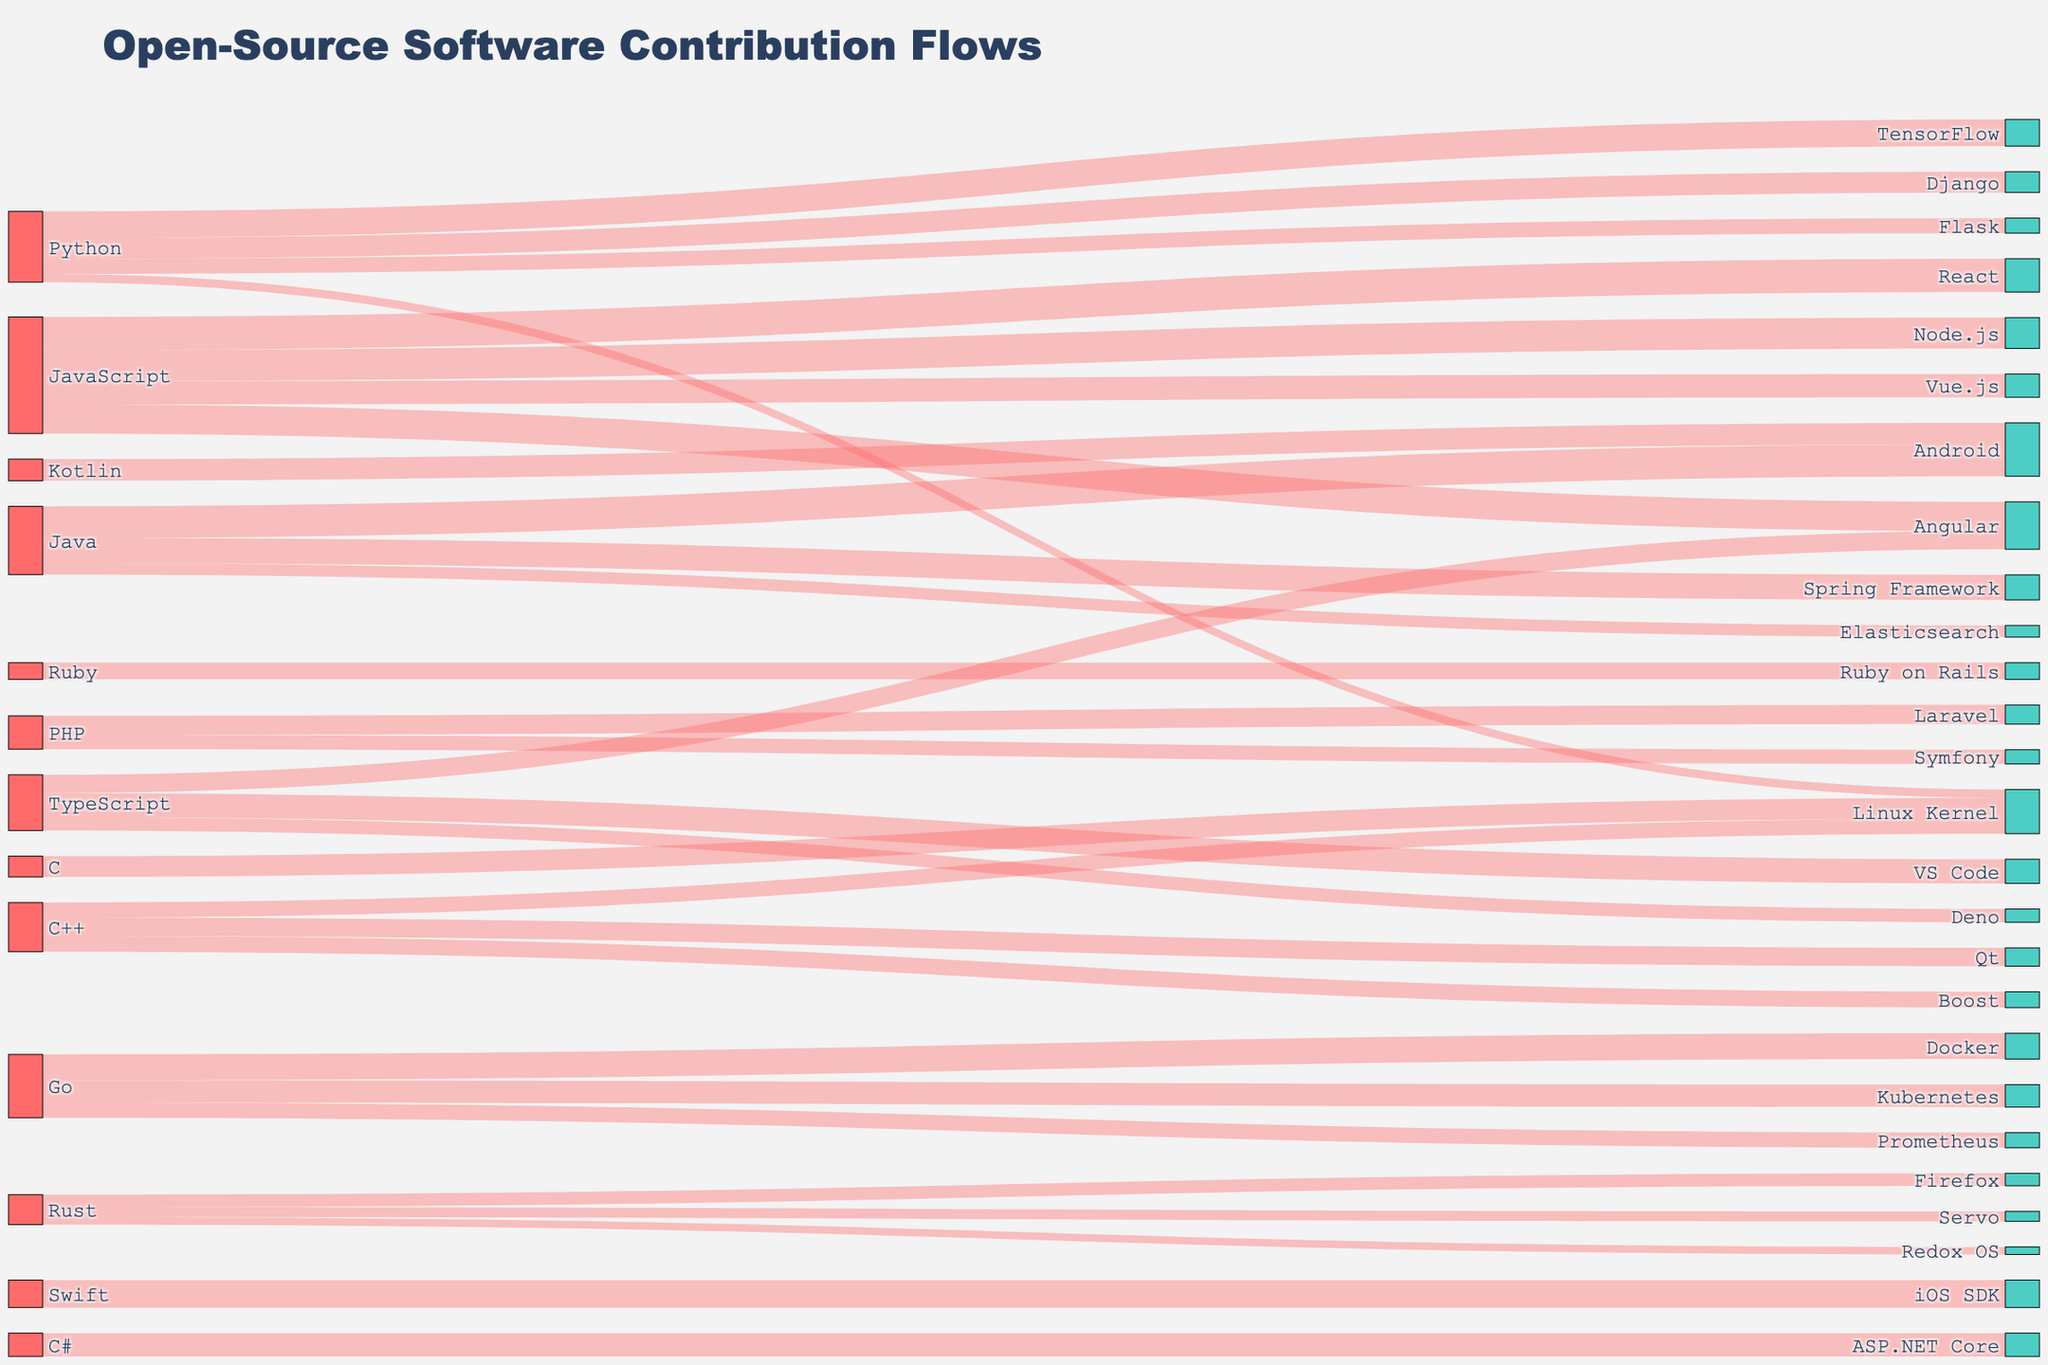Which programming language contributes the most to its open-source projects? By looking at the Sankey diagram, we notice that the width of links represents the number of contributions. The thickest link originates from JavaScript towards its projects React, Node.js, Vue.js, and Angular. Summing them up, JavaScript has 4000 + 3700 + 2800 + 3500 = 14000 contributions, which is the highest among all languages.
Answer: JavaScript How many contributions does Python have across all its projects? Python contributes to Django, Flask, TensorFlow, and the Linux Kernel. Adding these values, we get 2500 + 1800 + 3200 + 1000 = 8500 contributions.
Answer: 8500 Which project receives the highest number of contributions overall? By examining the width of the links and the numbers attached, TensorFlow appears to have the highest contributions from Python, totaling 3200.
Answer: TensorFlow Compare contributions to Laravel vs. Node.js. Which receives higher contributions and by how much? Laravel receives contributions from PHP (2300), while Node.js receives contributions from JavaScript (3700). The difference is 3700 - 2300 = 1400 in favor of Node.js.
Answer: Node.js by 1400 What is the total contribution to the Linux Kernel from all languages? Contributions to the Linux Kernel come from Python, C++, and C. Adding these up, 1000 + 1800 + 2500 = 5300.
Answer: 5300 Which language has the smallest total number of contributions and what is the total? Both Rust and Ruby show relatively fewer contributions. Summing up Rust (1500 + 1200 + 900 = 3600) and Ruby (2000), Ruby has the smallest total of 2000.
Answer: Ruby with 2000 Does TypeScript contribute more to VS Code or Angular, and what's the difference in contributions? TypeScript contributes 2900 to VS Code and 2200 to Angular. The difference is 2900 - 2200 = 700.
Answer: VS Code by 700 Which project shows contributions from multiple languages? The Linux Kernel receives contributions from Python, C++, and C.
Answer: Linux Kernel What are the combined contributions to Android from different programming languages? Android receives contributions from Java and Kotlin. Summing these, 3800 (Java) + 2600 (Kotlin) = 6400.
Answer: 6400 How do Go's contributions compare between Kubernetes and Docker, and are they nearly equal? Go contributes 2700 to Kubernetes and 3100 to Docker. The difference is 3100 - 2700 = 400, which suggests they are not nearly equal, but they are quite similar.
Answer: They are similar but Docker has 400 more 